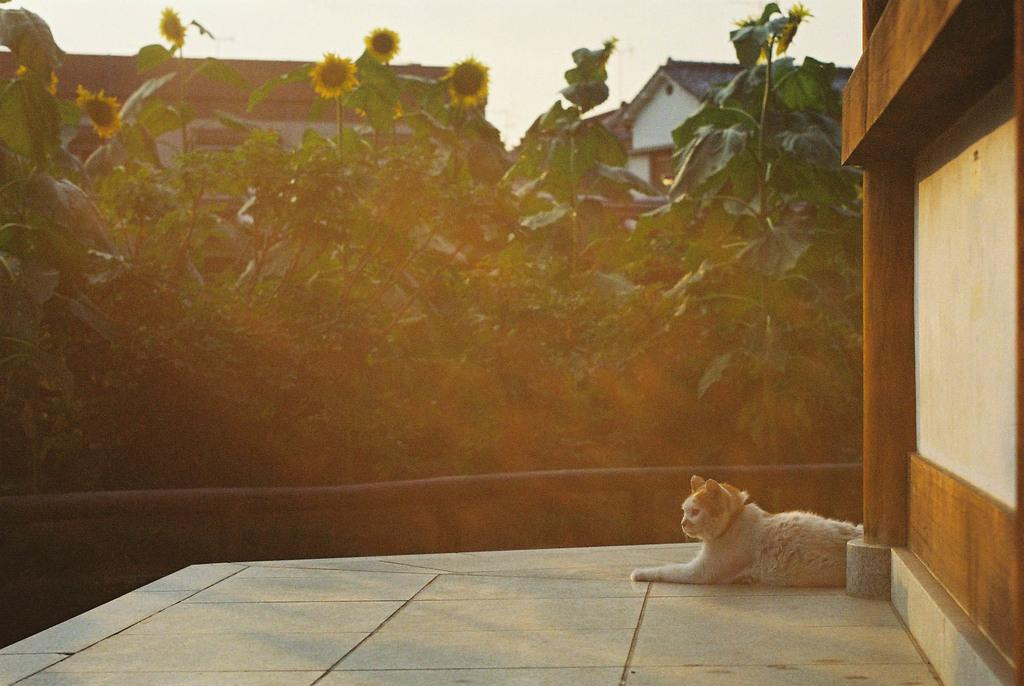What animal is located at the bottom side of the image? There is a cat at the bottom side of the image. What type of structures can be seen in the background of the image? There are houses in the background of the image. What type of vegetation is present in the background of the image? There are flower plants in the background of the image. What type of tin can be seen in the image? There is no tin present in the image. What type of birds are flying in the image? There are no birds present in the image. 